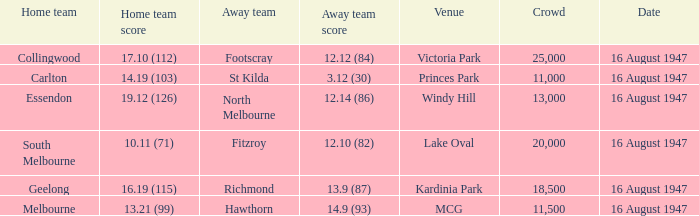What was the total size of the crowd when the away team scored 12.10 (82)? 20000.0. 